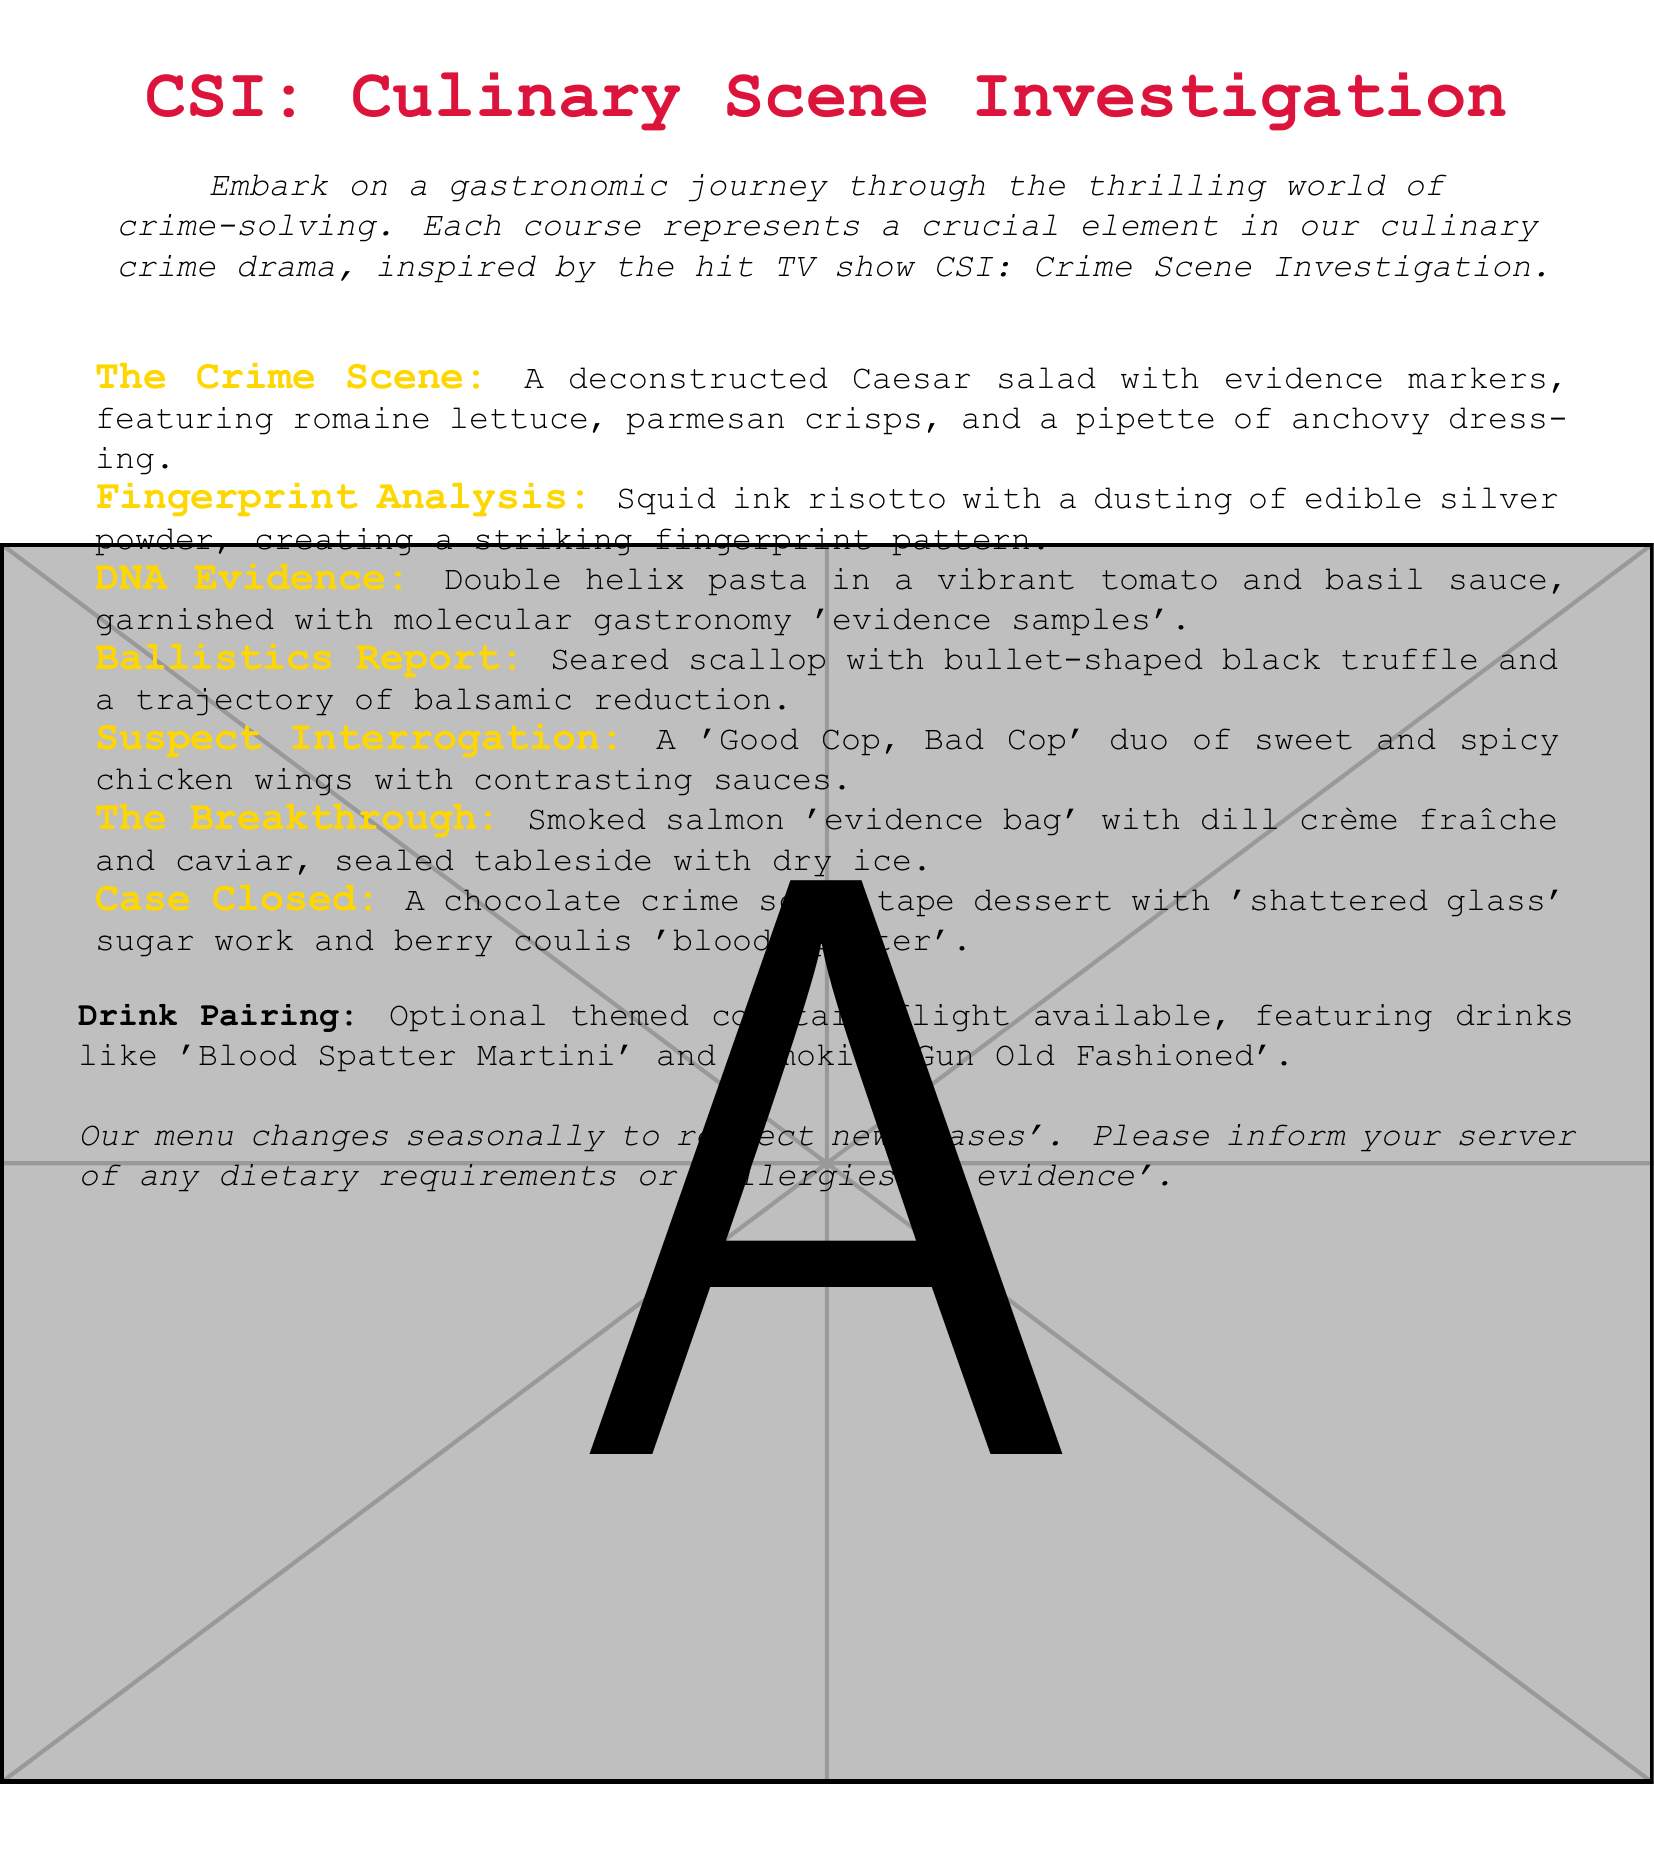What is the title of the menu? The title of the menu indicates the theme and name of the dining experience provided.
Answer: CSI: Culinary Scene Investigation How many courses are included in the tasting menu? The tasting menu outlines a progression of dishes, each crafted to resemble a clue or plot twist from a crime drama.
Answer: Seven What is featured in 'The Crime Scene' dish? The dish description provides specific ingredients that make up the deconstructed salad with evidence elements.
Answer: Romaine lettuce, parmesan crisps, and a pipette of anchovy dressing Which dish is described as having a 'trajectory of balsamic reduction'? This question references the specific terminology used to highlight a characteristic of the dish related to crime analysis.
Answer: Ballistics Report What theme is the optional cocktail flight based on? The drink details suggest an overarching theme aligned with the culinary experience, which complements the food.
Answer: Crime-themed In 'The Breakthrough' dish, what ingredient is used to seal the presentation? The sealing method adds a dramatic flair to the presentation and is mentioned within the description.
Answer: Dry ice What type of dessert is featured in 'Case Closed'? The dessert name implies its connection to the menu's overall crime theme while also being creatively described.
Answer: Chocolate crime scene tape dessert 